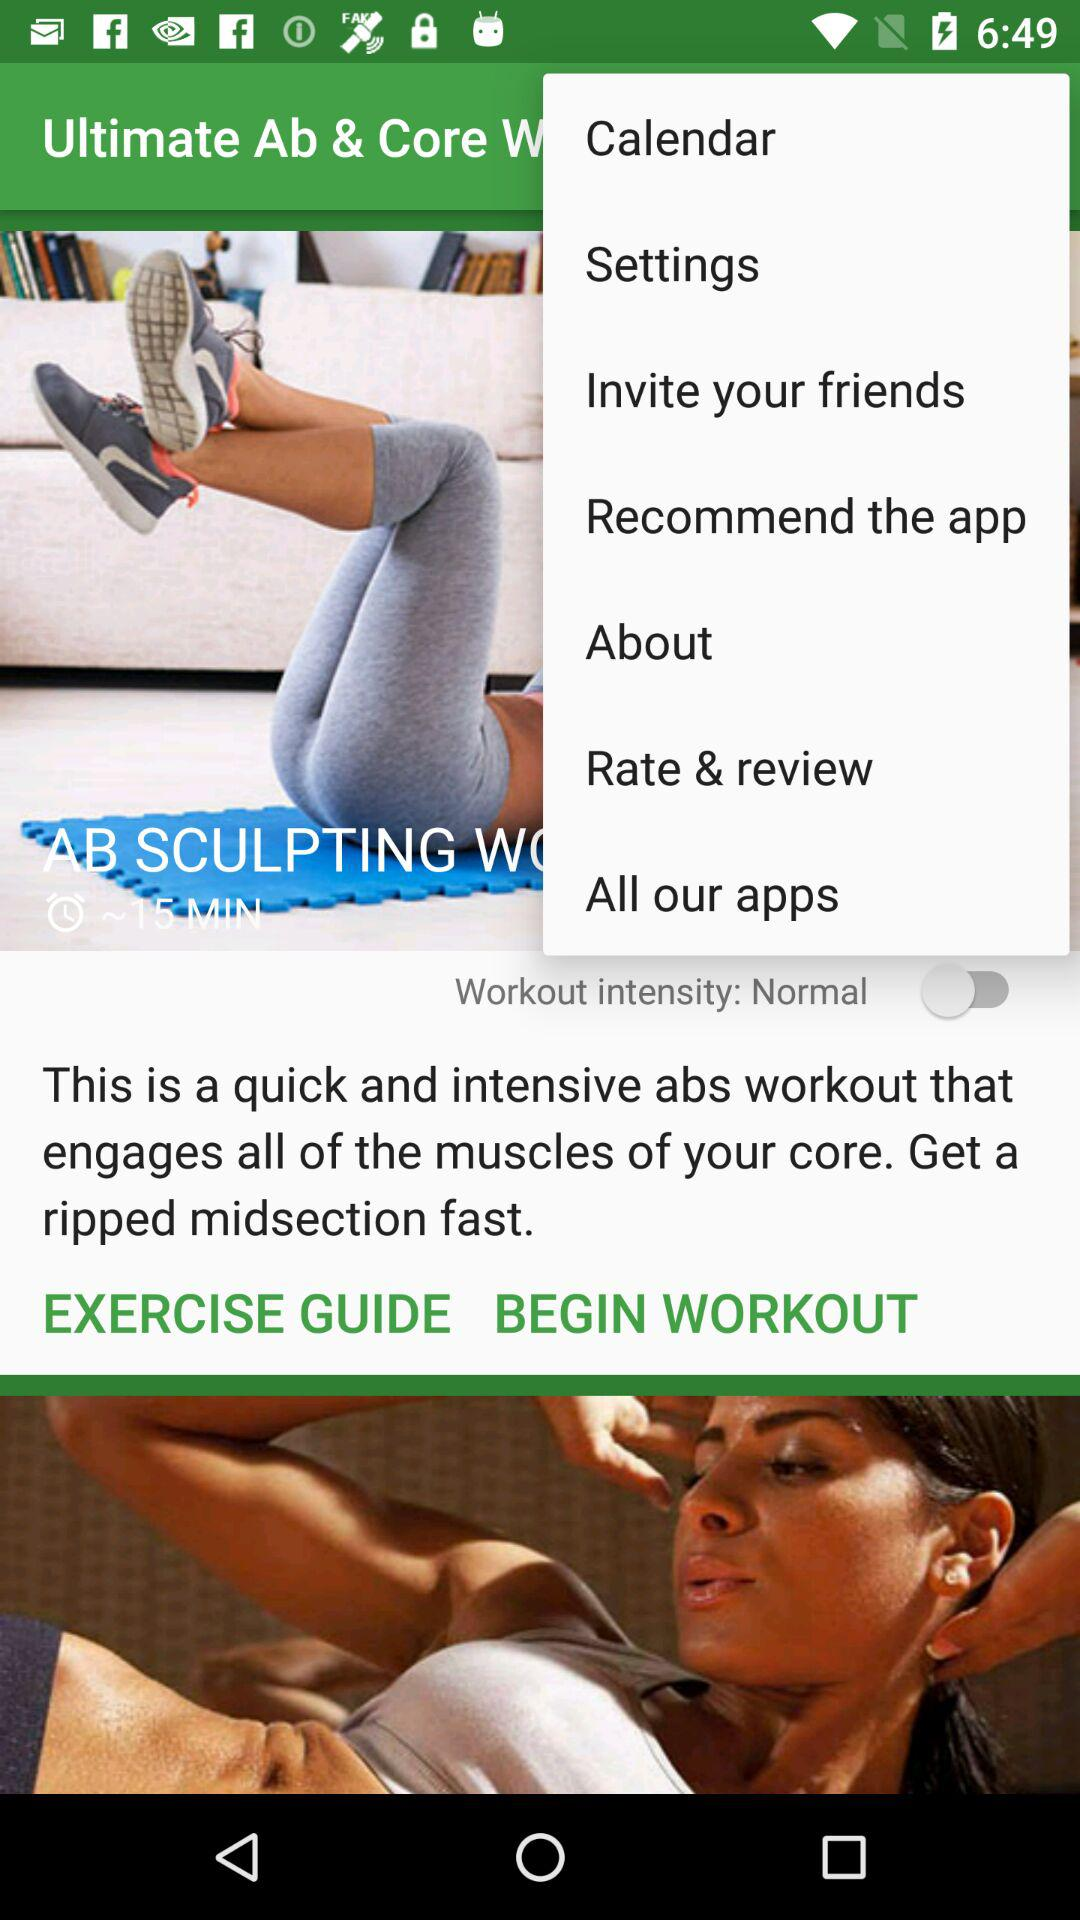What is the duration of the "AB SCULPTING WORKOUT" video? The duration is 15 minutes. 